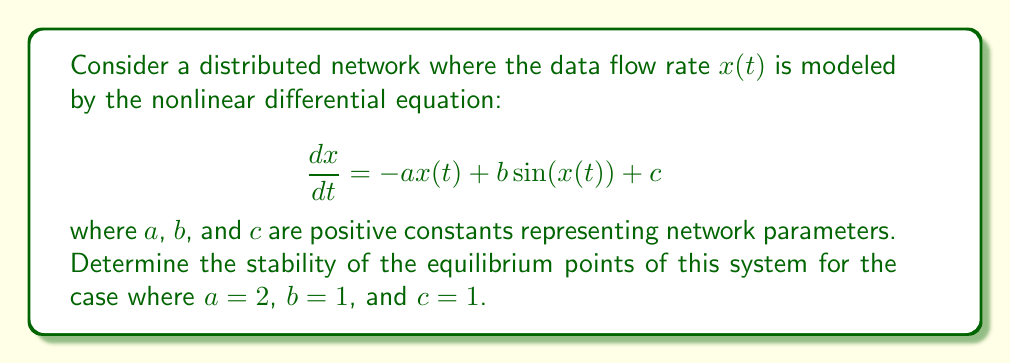Solve this math problem. To determine the stability of the nonlinear system, we follow these steps:

1) Find the equilibrium points by setting $\frac{dx}{dt} = 0$:

   $$0 = -2x + \sin(x) + 1$$

2) This equation cannot be solved analytically. However, we can observe that there is at least one equilibrium point because the left-hand side is continuous and crosses zero (by the intermediate value theorem).

3) To analyze stability, we linearize the system around each equilibrium point. Let $x^*$ be an equilibrium point. The linearized system is:

   $$\frac{d\Delta x}{dt} = f'(x^*)\Delta x$$

   where $f'(x) = -2 + \cos(x)$ is the derivative of the right-hand side of the original equation.

4) The stability of each equilibrium point is determined by the sign of $f'(x^*)$:
   - If $f'(x^*) < 0$, the equilibrium is stable.
   - If $f'(x^*) > 0$, the equilibrium is unstable.

5) We can determine the number and approximate locations of equilibrium points graphically or numerically. In this case, there is only one equilibrium point, approximately at $x^* \approx 0.9$.

6) Evaluate $f'(x^*)$ at this point:

   $$f'(0.9) \approx -2 + \cos(0.9) \approx -2 + 0.62 = -1.38 < 0$$

7) Since $f'(x^*) < 0$, the equilibrium point is stable.

This means that for small perturbations around the equilibrium data flow rate, the system will tend to return to this equilibrium state, ensuring a stable data flow in the distributed network.
Answer: The system has one stable equilibrium point at $x^* \approx 0.9$. 